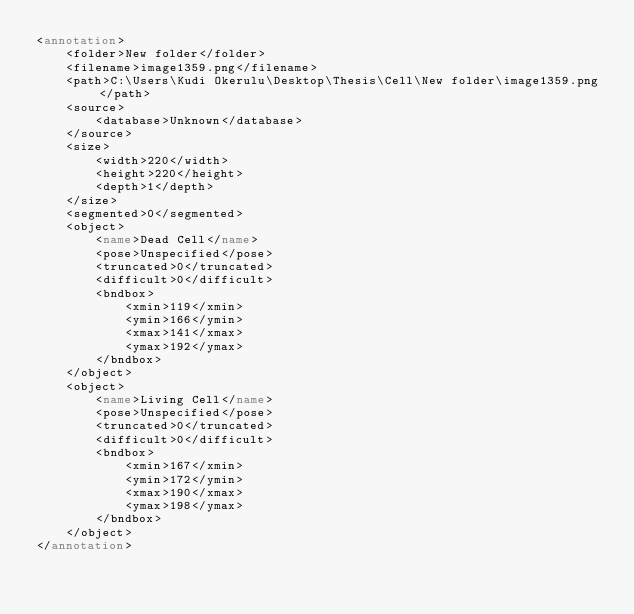<code> <loc_0><loc_0><loc_500><loc_500><_XML_><annotation>
	<folder>New folder</folder>
	<filename>image1359.png</filename>
	<path>C:\Users\Kudi Okerulu\Desktop\Thesis\Cell\New folder\image1359.png</path>
	<source>
		<database>Unknown</database>
	</source>
	<size>
		<width>220</width>
		<height>220</height>
		<depth>1</depth>
	</size>
	<segmented>0</segmented>
	<object>
		<name>Dead Cell</name>
		<pose>Unspecified</pose>
		<truncated>0</truncated>
		<difficult>0</difficult>
		<bndbox>
			<xmin>119</xmin>
			<ymin>166</ymin>
			<xmax>141</xmax>
			<ymax>192</ymax>
		</bndbox>
	</object>
	<object>
		<name>Living Cell</name>
		<pose>Unspecified</pose>
		<truncated>0</truncated>
		<difficult>0</difficult>
		<bndbox>
			<xmin>167</xmin>
			<ymin>172</ymin>
			<xmax>190</xmax>
			<ymax>198</ymax>
		</bndbox>
	</object>
</annotation>
</code> 